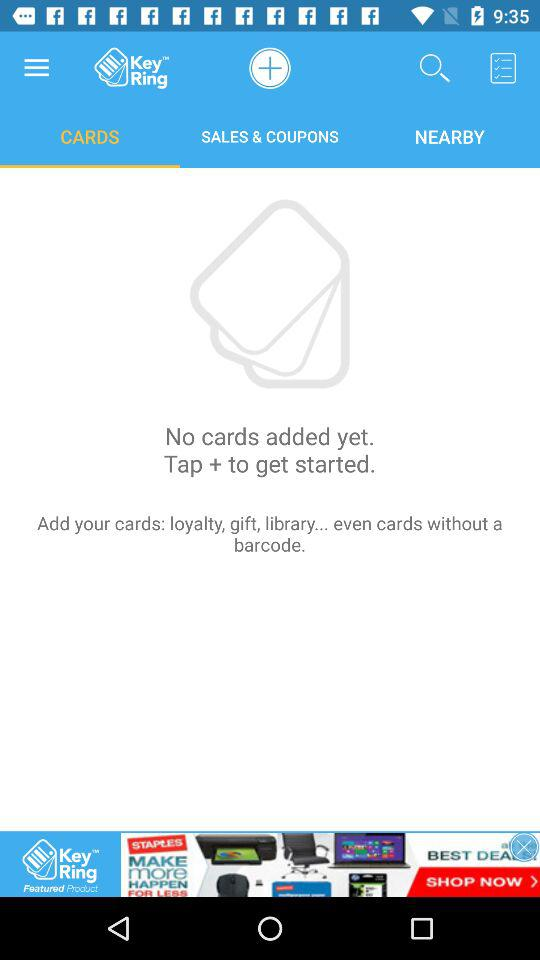How many cards are added to the app?
Answer the question using a single word or phrase. 0 